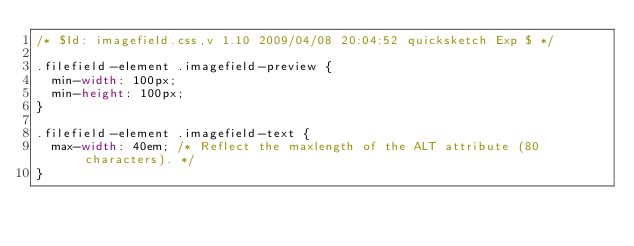<code> <loc_0><loc_0><loc_500><loc_500><_CSS_>/* $Id: imagefield.css,v 1.10 2009/04/08 20:04:52 quicksketch Exp $ */

.filefield-element .imagefield-preview {
  min-width: 100px;
  min-height: 100px;
}

.filefield-element .imagefield-text {
  max-width: 40em; /* Reflect the maxlength of the ALT attribute (80 characters). */
}
</code> 